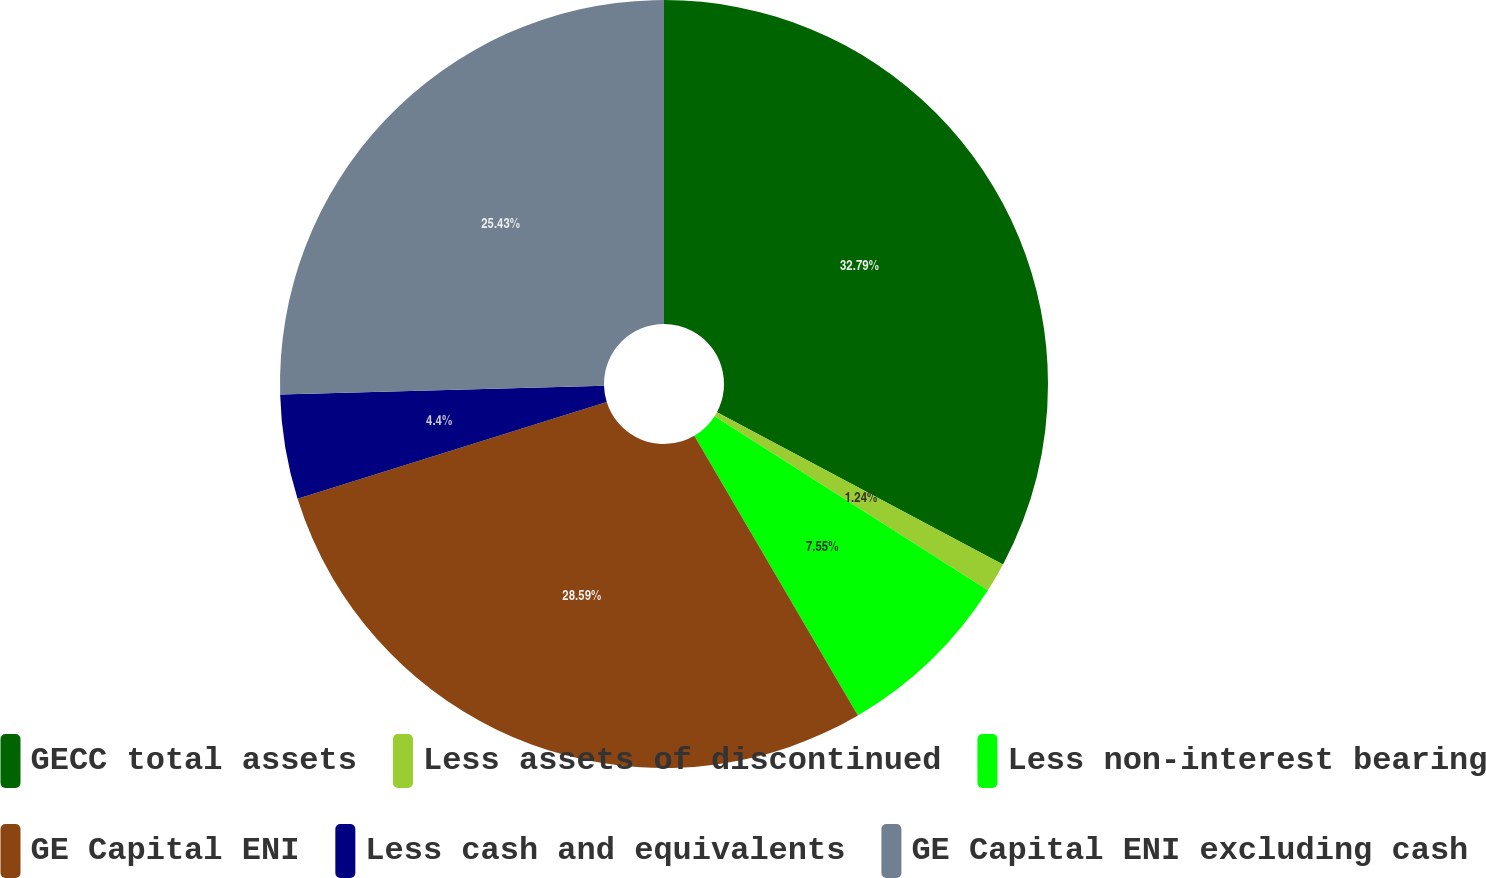<chart> <loc_0><loc_0><loc_500><loc_500><pie_chart><fcel>GECC total assets<fcel>Less assets of discontinued<fcel>Less non-interest bearing<fcel>GE Capital ENI<fcel>Less cash and equivalents<fcel>GE Capital ENI excluding cash<nl><fcel>32.78%<fcel>1.24%<fcel>7.55%<fcel>28.59%<fcel>4.4%<fcel>25.43%<nl></chart> 